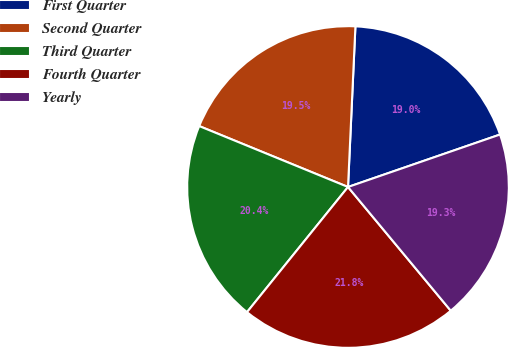Convert chart to OTSL. <chart><loc_0><loc_0><loc_500><loc_500><pie_chart><fcel>First Quarter<fcel>Second Quarter<fcel>Third Quarter<fcel>Fourth Quarter<fcel>Yearly<nl><fcel>18.98%<fcel>19.55%<fcel>20.38%<fcel>21.84%<fcel>19.26%<nl></chart> 